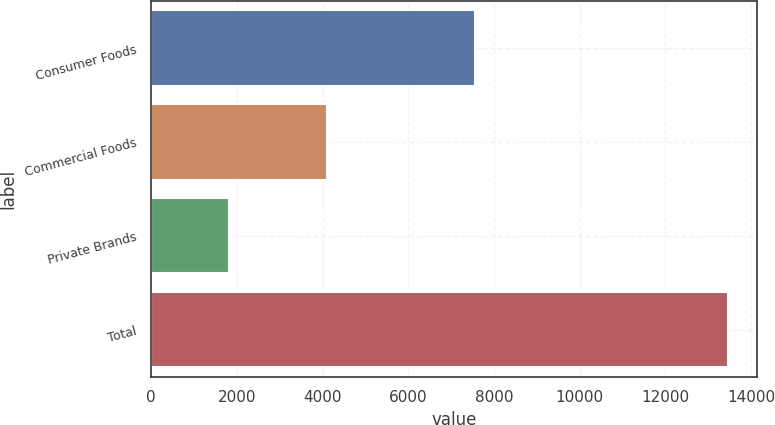Convert chart to OTSL. <chart><loc_0><loc_0><loc_500><loc_500><bar_chart><fcel>Consumer Foods<fcel>Commercial Foods<fcel>Private Brands<fcel>Total<nl><fcel>7551.4<fcel>4109.7<fcel>1808.2<fcel>13469.3<nl></chart> 